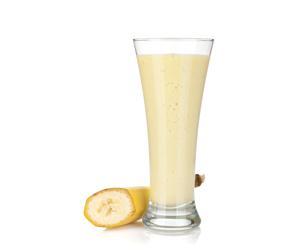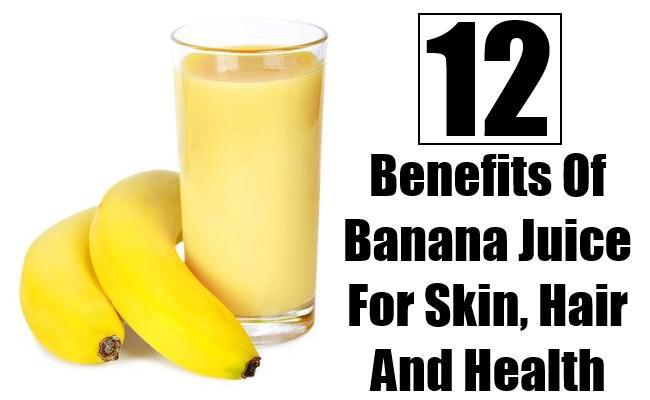The first image is the image on the left, the second image is the image on the right. Evaluate the accuracy of this statement regarding the images: "there is a glass of banana smoothie with a straw and at least 4 whole bananas next to it". Is it true? Answer yes or no. No. The first image is the image on the left, the second image is the image on the right. Considering the images on both sides, is "The glass in the image to the right, it has a straw in it." valid? Answer yes or no. No. 